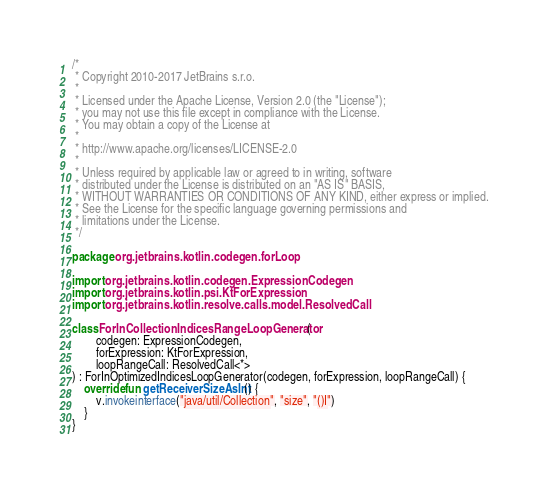<code> <loc_0><loc_0><loc_500><loc_500><_Kotlin_>/*
 * Copyright 2010-2017 JetBrains s.r.o.
 *
 * Licensed under the Apache License, Version 2.0 (the "License");
 * you may not use this file except in compliance with the License.
 * You may obtain a copy of the License at
 *
 * http://www.apache.org/licenses/LICENSE-2.0
 *
 * Unless required by applicable law or agreed to in writing, software
 * distributed under the License is distributed on an "AS IS" BASIS,
 * WITHOUT WARRANTIES OR CONDITIONS OF ANY KIND, either express or implied.
 * See the License for the specific language governing permissions and
 * limitations under the License.
 */

package org.jetbrains.kotlin.codegen.forLoop

import org.jetbrains.kotlin.codegen.ExpressionCodegen
import org.jetbrains.kotlin.psi.KtForExpression
import org.jetbrains.kotlin.resolve.calls.model.ResolvedCall

class ForInCollectionIndicesRangeLoopGenerator(
        codegen: ExpressionCodegen,
        forExpression: KtForExpression,
        loopRangeCall: ResolvedCall<*>
) : ForInOptimizedIndicesLoopGenerator(codegen, forExpression, loopRangeCall) {
    override fun getReceiverSizeAsInt() {
        v.invokeinterface("java/util/Collection", "size", "()I")
    }
}
</code> 